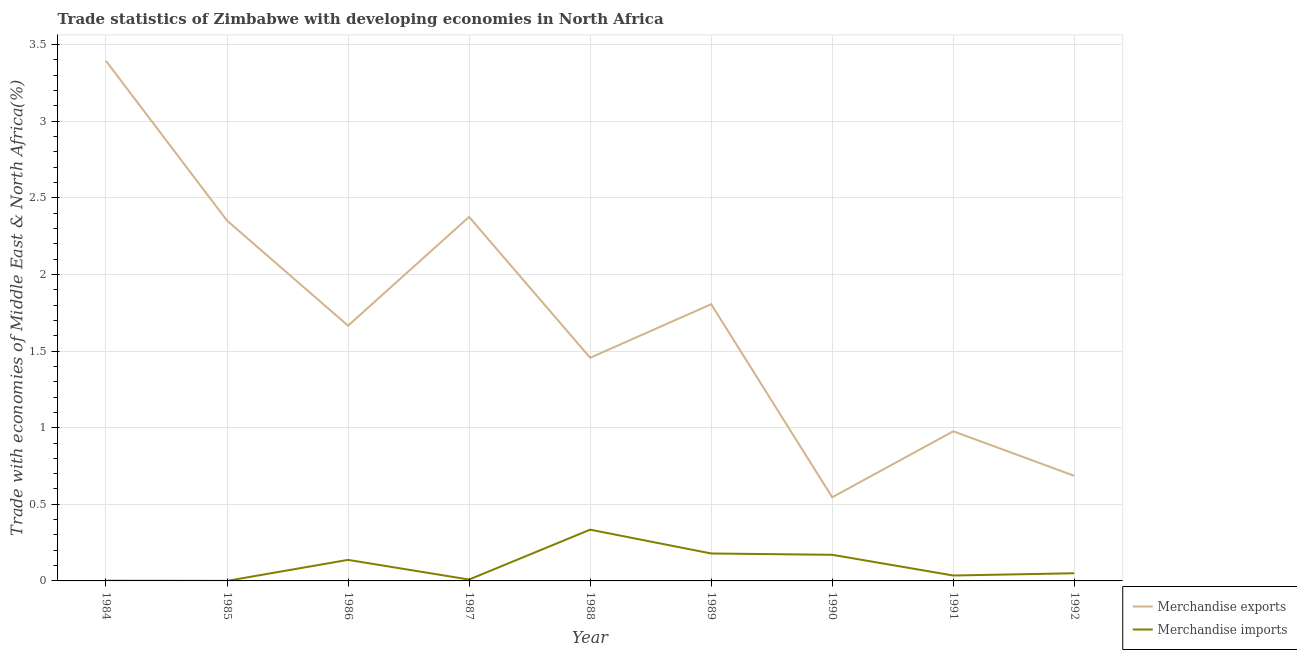How many different coloured lines are there?
Your response must be concise. 2. Is the number of lines equal to the number of legend labels?
Keep it short and to the point. Yes. What is the merchandise exports in 1984?
Provide a short and direct response. 3.39. Across all years, what is the maximum merchandise imports?
Your response must be concise. 0.33. Across all years, what is the minimum merchandise exports?
Give a very brief answer. 0.55. What is the total merchandise exports in the graph?
Your answer should be very brief. 15.26. What is the difference between the merchandise exports in 1987 and that in 1992?
Ensure brevity in your answer.  1.69. What is the difference between the merchandise exports in 1989 and the merchandise imports in 1987?
Offer a very short reply. 1.8. What is the average merchandise exports per year?
Offer a terse response. 1.7. In the year 1991, what is the difference between the merchandise imports and merchandise exports?
Keep it short and to the point. -0.94. What is the ratio of the merchandise exports in 1990 to that in 1992?
Make the answer very short. 0.8. Is the merchandise imports in 1985 less than that in 1988?
Your response must be concise. Yes. Is the difference between the merchandise imports in 1990 and 1992 greater than the difference between the merchandise exports in 1990 and 1992?
Keep it short and to the point. Yes. What is the difference between the highest and the second highest merchandise exports?
Your answer should be very brief. 1.02. What is the difference between the highest and the lowest merchandise imports?
Offer a very short reply. 0.33. Is the merchandise imports strictly greater than the merchandise exports over the years?
Your response must be concise. No. How many years are there in the graph?
Your answer should be very brief. 9. What is the difference between two consecutive major ticks on the Y-axis?
Ensure brevity in your answer.  0.5. Are the values on the major ticks of Y-axis written in scientific E-notation?
Ensure brevity in your answer.  No. Does the graph contain any zero values?
Offer a terse response. No. Does the graph contain grids?
Give a very brief answer. Yes. How many legend labels are there?
Your answer should be compact. 2. How are the legend labels stacked?
Make the answer very short. Vertical. What is the title of the graph?
Make the answer very short. Trade statistics of Zimbabwe with developing economies in North Africa. What is the label or title of the Y-axis?
Ensure brevity in your answer.  Trade with economies of Middle East & North Africa(%). What is the Trade with economies of Middle East & North Africa(%) in Merchandise exports in 1984?
Provide a short and direct response. 3.39. What is the Trade with economies of Middle East & North Africa(%) of Merchandise imports in 1984?
Offer a terse response. 0. What is the Trade with economies of Middle East & North Africa(%) in Merchandise exports in 1985?
Offer a terse response. 2.35. What is the Trade with economies of Middle East & North Africa(%) in Merchandise imports in 1985?
Your answer should be very brief. 0. What is the Trade with economies of Middle East & North Africa(%) of Merchandise exports in 1986?
Provide a short and direct response. 1.67. What is the Trade with economies of Middle East & North Africa(%) of Merchandise imports in 1986?
Keep it short and to the point. 0.14. What is the Trade with economies of Middle East & North Africa(%) of Merchandise exports in 1987?
Offer a very short reply. 2.38. What is the Trade with economies of Middle East & North Africa(%) of Merchandise imports in 1987?
Provide a succinct answer. 0.01. What is the Trade with economies of Middle East & North Africa(%) of Merchandise exports in 1988?
Make the answer very short. 1.46. What is the Trade with economies of Middle East & North Africa(%) in Merchandise imports in 1988?
Keep it short and to the point. 0.33. What is the Trade with economies of Middle East & North Africa(%) in Merchandise exports in 1989?
Give a very brief answer. 1.81. What is the Trade with economies of Middle East & North Africa(%) of Merchandise imports in 1989?
Your answer should be very brief. 0.18. What is the Trade with economies of Middle East & North Africa(%) of Merchandise exports in 1990?
Your response must be concise. 0.55. What is the Trade with economies of Middle East & North Africa(%) in Merchandise imports in 1990?
Your answer should be compact. 0.17. What is the Trade with economies of Middle East & North Africa(%) of Merchandise exports in 1991?
Offer a terse response. 0.98. What is the Trade with economies of Middle East & North Africa(%) in Merchandise imports in 1991?
Make the answer very short. 0.04. What is the Trade with economies of Middle East & North Africa(%) of Merchandise exports in 1992?
Give a very brief answer. 0.69. What is the Trade with economies of Middle East & North Africa(%) of Merchandise imports in 1992?
Provide a short and direct response. 0.05. Across all years, what is the maximum Trade with economies of Middle East & North Africa(%) of Merchandise exports?
Your response must be concise. 3.39. Across all years, what is the maximum Trade with economies of Middle East & North Africa(%) in Merchandise imports?
Your response must be concise. 0.33. Across all years, what is the minimum Trade with economies of Middle East & North Africa(%) in Merchandise exports?
Offer a terse response. 0.55. Across all years, what is the minimum Trade with economies of Middle East & North Africa(%) in Merchandise imports?
Give a very brief answer. 0. What is the total Trade with economies of Middle East & North Africa(%) in Merchandise exports in the graph?
Provide a succinct answer. 15.26. What is the total Trade with economies of Middle East & North Africa(%) in Merchandise imports in the graph?
Make the answer very short. 0.92. What is the difference between the Trade with economies of Middle East & North Africa(%) of Merchandise exports in 1984 and that in 1985?
Give a very brief answer. 1.04. What is the difference between the Trade with economies of Middle East & North Africa(%) of Merchandise imports in 1984 and that in 1985?
Make the answer very short. 0. What is the difference between the Trade with economies of Middle East & North Africa(%) in Merchandise exports in 1984 and that in 1986?
Offer a terse response. 1.73. What is the difference between the Trade with economies of Middle East & North Africa(%) of Merchandise imports in 1984 and that in 1986?
Your answer should be compact. -0.14. What is the difference between the Trade with economies of Middle East & North Africa(%) in Merchandise exports in 1984 and that in 1987?
Provide a short and direct response. 1.02. What is the difference between the Trade with economies of Middle East & North Africa(%) in Merchandise imports in 1984 and that in 1987?
Your response must be concise. -0.01. What is the difference between the Trade with economies of Middle East & North Africa(%) in Merchandise exports in 1984 and that in 1988?
Offer a terse response. 1.94. What is the difference between the Trade with economies of Middle East & North Africa(%) in Merchandise imports in 1984 and that in 1988?
Ensure brevity in your answer.  -0.33. What is the difference between the Trade with economies of Middle East & North Africa(%) in Merchandise exports in 1984 and that in 1989?
Your answer should be compact. 1.59. What is the difference between the Trade with economies of Middle East & North Africa(%) in Merchandise imports in 1984 and that in 1989?
Provide a short and direct response. -0.18. What is the difference between the Trade with economies of Middle East & North Africa(%) in Merchandise exports in 1984 and that in 1990?
Your answer should be very brief. 2.85. What is the difference between the Trade with economies of Middle East & North Africa(%) in Merchandise imports in 1984 and that in 1990?
Offer a terse response. -0.17. What is the difference between the Trade with economies of Middle East & North Africa(%) in Merchandise exports in 1984 and that in 1991?
Provide a succinct answer. 2.42. What is the difference between the Trade with economies of Middle East & North Africa(%) in Merchandise imports in 1984 and that in 1991?
Your answer should be compact. -0.03. What is the difference between the Trade with economies of Middle East & North Africa(%) of Merchandise exports in 1984 and that in 1992?
Provide a succinct answer. 2.71. What is the difference between the Trade with economies of Middle East & North Africa(%) of Merchandise imports in 1984 and that in 1992?
Your answer should be very brief. -0.05. What is the difference between the Trade with economies of Middle East & North Africa(%) in Merchandise exports in 1985 and that in 1986?
Provide a succinct answer. 0.69. What is the difference between the Trade with economies of Middle East & North Africa(%) in Merchandise imports in 1985 and that in 1986?
Provide a short and direct response. -0.14. What is the difference between the Trade with economies of Middle East & North Africa(%) of Merchandise exports in 1985 and that in 1987?
Your answer should be very brief. -0.02. What is the difference between the Trade with economies of Middle East & North Africa(%) of Merchandise imports in 1985 and that in 1987?
Offer a terse response. -0.01. What is the difference between the Trade with economies of Middle East & North Africa(%) in Merchandise exports in 1985 and that in 1988?
Your response must be concise. 0.9. What is the difference between the Trade with economies of Middle East & North Africa(%) of Merchandise imports in 1985 and that in 1988?
Ensure brevity in your answer.  -0.33. What is the difference between the Trade with economies of Middle East & North Africa(%) of Merchandise exports in 1985 and that in 1989?
Offer a terse response. 0.55. What is the difference between the Trade with economies of Middle East & North Africa(%) in Merchandise imports in 1985 and that in 1989?
Your response must be concise. -0.18. What is the difference between the Trade with economies of Middle East & North Africa(%) in Merchandise exports in 1985 and that in 1990?
Keep it short and to the point. 1.81. What is the difference between the Trade with economies of Middle East & North Africa(%) in Merchandise imports in 1985 and that in 1990?
Offer a very short reply. -0.17. What is the difference between the Trade with economies of Middle East & North Africa(%) in Merchandise exports in 1985 and that in 1991?
Your answer should be compact. 1.38. What is the difference between the Trade with economies of Middle East & North Africa(%) of Merchandise imports in 1985 and that in 1991?
Your answer should be very brief. -0.04. What is the difference between the Trade with economies of Middle East & North Africa(%) in Merchandise exports in 1985 and that in 1992?
Provide a short and direct response. 1.67. What is the difference between the Trade with economies of Middle East & North Africa(%) of Merchandise imports in 1985 and that in 1992?
Your answer should be very brief. -0.05. What is the difference between the Trade with economies of Middle East & North Africa(%) in Merchandise exports in 1986 and that in 1987?
Offer a very short reply. -0.71. What is the difference between the Trade with economies of Middle East & North Africa(%) in Merchandise imports in 1986 and that in 1987?
Offer a very short reply. 0.13. What is the difference between the Trade with economies of Middle East & North Africa(%) in Merchandise exports in 1986 and that in 1988?
Your answer should be compact. 0.21. What is the difference between the Trade with economies of Middle East & North Africa(%) in Merchandise imports in 1986 and that in 1988?
Provide a succinct answer. -0.2. What is the difference between the Trade with economies of Middle East & North Africa(%) in Merchandise exports in 1986 and that in 1989?
Provide a succinct answer. -0.14. What is the difference between the Trade with economies of Middle East & North Africa(%) of Merchandise imports in 1986 and that in 1989?
Make the answer very short. -0.04. What is the difference between the Trade with economies of Middle East & North Africa(%) in Merchandise exports in 1986 and that in 1990?
Your answer should be very brief. 1.12. What is the difference between the Trade with economies of Middle East & North Africa(%) of Merchandise imports in 1986 and that in 1990?
Offer a very short reply. -0.03. What is the difference between the Trade with economies of Middle East & North Africa(%) in Merchandise exports in 1986 and that in 1991?
Your answer should be very brief. 0.69. What is the difference between the Trade with economies of Middle East & North Africa(%) of Merchandise imports in 1986 and that in 1991?
Provide a short and direct response. 0.1. What is the difference between the Trade with economies of Middle East & North Africa(%) in Merchandise imports in 1986 and that in 1992?
Offer a very short reply. 0.09. What is the difference between the Trade with economies of Middle East & North Africa(%) of Merchandise exports in 1987 and that in 1988?
Your response must be concise. 0.92. What is the difference between the Trade with economies of Middle East & North Africa(%) in Merchandise imports in 1987 and that in 1988?
Your response must be concise. -0.33. What is the difference between the Trade with economies of Middle East & North Africa(%) of Merchandise exports in 1987 and that in 1989?
Offer a terse response. 0.57. What is the difference between the Trade with economies of Middle East & North Africa(%) in Merchandise imports in 1987 and that in 1989?
Offer a terse response. -0.17. What is the difference between the Trade with economies of Middle East & North Africa(%) in Merchandise exports in 1987 and that in 1990?
Offer a very short reply. 1.83. What is the difference between the Trade with economies of Middle East & North Africa(%) in Merchandise imports in 1987 and that in 1990?
Your answer should be compact. -0.16. What is the difference between the Trade with economies of Middle East & North Africa(%) of Merchandise exports in 1987 and that in 1991?
Give a very brief answer. 1.4. What is the difference between the Trade with economies of Middle East & North Africa(%) in Merchandise imports in 1987 and that in 1991?
Ensure brevity in your answer.  -0.03. What is the difference between the Trade with economies of Middle East & North Africa(%) in Merchandise exports in 1987 and that in 1992?
Keep it short and to the point. 1.69. What is the difference between the Trade with economies of Middle East & North Africa(%) in Merchandise imports in 1987 and that in 1992?
Offer a terse response. -0.04. What is the difference between the Trade with economies of Middle East & North Africa(%) in Merchandise exports in 1988 and that in 1989?
Give a very brief answer. -0.35. What is the difference between the Trade with economies of Middle East & North Africa(%) of Merchandise imports in 1988 and that in 1989?
Ensure brevity in your answer.  0.16. What is the difference between the Trade with economies of Middle East & North Africa(%) in Merchandise exports in 1988 and that in 1990?
Ensure brevity in your answer.  0.91. What is the difference between the Trade with economies of Middle East & North Africa(%) of Merchandise imports in 1988 and that in 1990?
Make the answer very short. 0.16. What is the difference between the Trade with economies of Middle East & North Africa(%) of Merchandise exports in 1988 and that in 1991?
Provide a short and direct response. 0.48. What is the difference between the Trade with economies of Middle East & North Africa(%) in Merchandise imports in 1988 and that in 1991?
Provide a short and direct response. 0.3. What is the difference between the Trade with economies of Middle East & North Africa(%) in Merchandise exports in 1988 and that in 1992?
Keep it short and to the point. 0.77. What is the difference between the Trade with economies of Middle East & North Africa(%) in Merchandise imports in 1988 and that in 1992?
Provide a short and direct response. 0.28. What is the difference between the Trade with economies of Middle East & North Africa(%) of Merchandise exports in 1989 and that in 1990?
Offer a terse response. 1.26. What is the difference between the Trade with economies of Middle East & North Africa(%) of Merchandise imports in 1989 and that in 1990?
Offer a terse response. 0.01. What is the difference between the Trade with economies of Middle East & North Africa(%) of Merchandise exports in 1989 and that in 1991?
Offer a very short reply. 0.83. What is the difference between the Trade with economies of Middle East & North Africa(%) in Merchandise imports in 1989 and that in 1991?
Ensure brevity in your answer.  0.14. What is the difference between the Trade with economies of Middle East & North Africa(%) in Merchandise exports in 1989 and that in 1992?
Your response must be concise. 1.12. What is the difference between the Trade with economies of Middle East & North Africa(%) in Merchandise imports in 1989 and that in 1992?
Provide a succinct answer. 0.13. What is the difference between the Trade with economies of Middle East & North Africa(%) in Merchandise exports in 1990 and that in 1991?
Ensure brevity in your answer.  -0.43. What is the difference between the Trade with economies of Middle East & North Africa(%) of Merchandise imports in 1990 and that in 1991?
Provide a short and direct response. 0.14. What is the difference between the Trade with economies of Middle East & North Africa(%) of Merchandise exports in 1990 and that in 1992?
Offer a terse response. -0.14. What is the difference between the Trade with economies of Middle East & North Africa(%) of Merchandise imports in 1990 and that in 1992?
Provide a succinct answer. 0.12. What is the difference between the Trade with economies of Middle East & North Africa(%) of Merchandise exports in 1991 and that in 1992?
Provide a short and direct response. 0.29. What is the difference between the Trade with economies of Middle East & North Africa(%) in Merchandise imports in 1991 and that in 1992?
Provide a short and direct response. -0.01. What is the difference between the Trade with economies of Middle East & North Africa(%) of Merchandise exports in 1984 and the Trade with economies of Middle East & North Africa(%) of Merchandise imports in 1985?
Ensure brevity in your answer.  3.39. What is the difference between the Trade with economies of Middle East & North Africa(%) in Merchandise exports in 1984 and the Trade with economies of Middle East & North Africa(%) in Merchandise imports in 1986?
Provide a short and direct response. 3.26. What is the difference between the Trade with economies of Middle East & North Africa(%) of Merchandise exports in 1984 and the Trade with economies of Middle East & North Africa(%) of Merchandise imports in 1987?
Make the answer very short. 3.38. What is the difference between the Trade with economies of Middle East & North Africa(%) of Merchandise exports in 1984 and the Trade with economies of Middle East & North Africa(%) of Merchandise imports in 1988?
Provide a short and direct response. 3.06. What is the difference between the Trade with economies of Middle East & North Africa(%) of Merchandise exports in 1984 and the Trade with economies of Middle East & North Africa(%) of Merchandise imports in 1989?
Your response must be concise. 3.21. What is the difference between the Trade with economies of Middle East & North Africa(%) of Merchandise exports in 1984 and the Trade with economies of Middle East & North Africa(%) of Merchandise imports in 1990?
Offer a very short reply. 3.22. What is the difference between the Trade with economies of Middle East & North Africa(%) in Merchandise exports in 1984 and the Trade with economies of Middle East & North Africa(%) in Merchandise imports in 1991?
Offer a very short reply. 3.36. What is the difference between the Trade with economies of Middle East & North Africa(%) of Merchandise exports in 1984 and the Trade with economies of Middle East & North Africa(%) of Merchandise imports in 1992?
Your answer should be compact. 3.34. What is the difference between the Trade with economies of Middle East & North Africa(%) of Merchandise exports in 1985 and the Trade with economies of Middle East & North Africa(%) of Merchandise imports in 1986?
Make the answer very short. 2.21. What is the difference between the Trade with economies of Middle East & North Africa(%) in Merchandise exports in 1985 and the Trade with economies of Middle East & North Africa(%) in Merchandise imports in 1987?
Your response must be concise. 2.34. What is the difference between the Trade with economies of Middle East & North Africa(%) of Merchandise exports in 1985 and the Trade with economies of Middle East & North Africa(%) of Merchandise imports in 1988?
Your answer should be very brief. 2.02. What is the difference between the Trade with economies of Middle East & North Africa(%) in Merchandise exports in 1985 and the Trade with economies of Middle East & North Africa(%) in Merchandise imports in 1989?
Make the answer very short. 2.17. What is the difference between the Trade with economies of Middle East & North Africa(%) in Merchandise exports in 1985 and the Trade with economies of Middle East & North Africa(%) in Merchandise imports in 1990?
Provide a succinct answer. 2.18. What is the difference between the Trade with economies of Middle East & North Africa(%) of Merchandise exports in 1985 and the Trade with economies of Middle East & North Africa(%) of Merchandise imports in 1991?
Offer a terse response. 2.32. What is the difference between the Trade with economies of Middle East & North Africa(%) of Merchandise exports in 1985 and the Trade with economies of Middle East & North Africa(%) of Merchandise imports in 1992?
Your answer should be very brief. 2.3. What is the difference between the Trade with economies of Middle East & North Africa(%) in Merchandise exports in 1986 and the Trade with economies of Middle East & North Africa(%) in Merchandise imports in 1987?
Provide a succinct answer. 1.66. What is the difference between the Trade with economies of Middle East & North Africa(%) in Merchandise exports in 1986 and the Trade with economies of Middle East & North Africa(%) in Merchandise imports in 1988?
Your answer should be very brief. 1.33. What is the difference between the Trade with economies of Middle East & North Africa(%) in Merchandise exports in 1986 and the Trade with economies of Middle East & North Africa(%) in Merchandise imports in 1989?
Offer a terse response. 1.49. What is the difference between the Trade with economies of Middle East & North Africa(%) in Merchandise exports in 1986 and the Trade with economies of Middle East & North Africa(%) in Merchandise imports in 1990?
Keep it short and to the point. 1.5. What is the difference between the Trade with economies of Middle East & North Africa(%) of Merchandise exports in 1986 and the Trade with economies of Middle East & North Africa(%) of Merchandise imports in 1991?
Provide a succinct answer. 1.63. What is the difference between the Trade with economies of Middle East & North Africa(%) of Merchandise exports in 1986 and the Trade with economies of Middle East & North Africa(%) of Merchandise imports in 1992?
Provide a succinct answer. 1.62. What is the difference between the Trade with economies of Middle East & North Africa(%) in Merchandise exports in 1987 and the Trade with economies of Middle East & North Africa(%) in Merchandise imports in 1988?
Give a very brief answer. 2.04. What is the difference between the Trade with economies of Middle East & North Africa(%) in Merchandise exports in 1987 and the Trade with economies of Middle East & North Africa(%) in Merchandise imports in 1989?
Offer a terse response. 2.2. What is the difference between the Trade with economies of Middle East & North Africa(%) of Merchandise exports in 1987 and the Trade with economies of Middle East & North Africa(%) of Merchandise imports in 1990?
Make the answer very short. 2.21. What is the difference between the Trade with economies of Middle East & North Africa(%) of Merchandise exports in 1987 and the Trade with economies of Middle East & North Africa(%) of Merchandise imports in 1991?
Keep it short and to the point. 2.34. What is the difference between the Trade with economies of Middle East & North Africa(%) in Merchandise exports in 1987 and the Trade with economies of Middle East & North Africa(%) in Merchandise imports in 1992?
Offer a terse response. 2.33. What is the difference between the Trade with economies of Middle East & North Africa(%) of Merchandise exports in 1988 and the Trade with economies of Middle East & North Africa(%) of Merchandise imports in 1989?
Your answer should be compact. 1.28. What is the difference between the Trade with economies of Middle East & North Africa(%) of Merchandise exports in 1988 and the Trade with economies of Middle East & North Africa(%) of Merchandise imports in 1990?
Your answer should be compact. 1.29. What is the difference between the Trade with economies of Middle East & North Africa(%) of Merchandise exports in 1988 and the Trade with economies of Middle East & North Africa(%) of Merchandise imports in 1991?
Your answer should be very brief. 1.42. What is the difference between the Trade with economies of Middle East & North Africa(%) in Merchandise exports in 1988 and the Trade with economies of Middle East & North Africa(%) in Merchandise imports in 1992?
Your answer should be compact. 1.41. What is the difference between the Trade with economies of Middle East & North Africa(%) of Merchandise exports in 1989 and the Trade with economies of Middle East & North Africa(%) of Merchandise imports in 1990?
Your answer should be compact. 1.64. What is the difference between the Trade with economies of Middle East & North Africa(%) of Merchandise exports in 1989 and the Trade with economies of Middle East & North Africa(%) of Merchandise imports in 1991?
Keep it short and to the point. 1.77. What is the difference between the Trade with economies of Middle East & North Africa(%) in Merchandise exports in 1989 and the Trade with economies of Middle East & North Africa(%) in Merchandise imports in 1992?
Your answer should be very brief. 1.76. What is the difference between the Trade with economies of Middle East & North Africa(%) of Merchandise exports in 1990 and the Trade with economies of Middle East & North Africa(%) of Merchandise imports in 1991?
Your answer should be compact. 0.51. What is the difference between the Trade with economies of Middle East & North Africa(%) of Merchandise exports in 1990 and the Trade with economies of Middle East & North Africa(%) of Merchandise imports in 1992?
Give a very brief answer. 0.5. What is the difference between the Trade with economies of Middle East & North Africa(%) in Merchandise exports in 1991 and the Trade with economies of Middle East & North Africa(%) in Merchandise imports in 1992?
Your response must be concise. 0.93. What is the average Trade with economies of Middle East & North Africa(%) in Merchandise exports per year?
Provide a short and direct response. 1.7. What is the average Trade with economies of Middle East & North Africa(%) in Merchandise imports per year?
Provide a succinct answer. 0.1. In the year 1984, what is the difference between the Trade with economies of Middle East & North Africa(%) of Merchandise exports and Trade with economies of Middle East & North Africa(%) of Merchandise imports?
Your answer should be very brief. 3.39. In the year 1985, what is the difference between the Trade with economies of Middle East & North Africa(%) of Merchandise exports and Trade with economies of Middle East & North Africa(%) of Merchandise imports?
Provide a succinct answer. 2.35. In the year 1986, what is the difference between the Trade with economies of Middle East & North Africa(%) in Merchandise exports and Trade with economies of Middle East & North Africa(%) in Merchandise imports?
Your answer should be very brief. 1.53. In the year 1987, what is the difference between the Trade with economies of Middle East & North Africa(%) of Merchandise exports and Trade with economies of Middle East & North Africa(%) of Merchandise imports?
Provide a short and direct response. 2.37. In the year 1988, what is the difference between the Trade with economies of Middle East & North Africa(%) of Merchandise exports and Trade with economies of Middle East & North Africa(%) of Merchandise imports?
Provide a short and direct response. 1.12. In the year 1989, what is the difference between the Trade with economies of Middle East & North Africa(%) in Merchandise exports and Trade with economies of Middle East & North Africa(%) in Merchandise imports?
Make the answer very short. 1.63. In the year 1990, what is the difference between the Trade with economies of Middle East & North Africa(%) in Merchandise exports and Trade with economies of Middle East & North Africa(%) in Merchandise imports?
Offer a very short reply. 0.38. In the year 1991, what is the difference between the Trade with economies of Middle East & North Africa(%) in Merchandise exports and Trade with economies of Middle East & North Africa(%) in Merchandise imports?
Give a very brief answer. 0.94. In the year 1992, what is the difference between the Trade with economies of Middle East & North Africa(%) in Merchandise exports and Trade with economies of Middle East & North Africa(%) in Merchandise imports?
Ensure brevity in your answer.  0.64. What is the ratio of the Trade with economies of Middle East & North Africa(%) in Merchandise exports in 1984 to that in 1985?
Offer a terse response. 1.44. What is the ratio of the Trade with economies of Middle East & North Africa(%) in Merchandise imports in 1984 to that in 1985?
Make the answer very short. 4.99. What is the ratio of the Trade with economies of Middle East & North Africa(%) of Merchandise exports in 1984 to that in 1986?
Offer a terse response. 2.04. What is the ratio of the Trade with economies of Middle East & North Africa(%) in Merchandise imports in 1984 to that in 1986?
Make the answer very short. 0.01. What is the ratio of the Trade with economies of Middle East & North Africa(%) of Merchandise exports in 1984 to that in 1987?
Make the answer very short. 1.43. What is the ratio of the Trade with economies of Middle East & North Africa(%) in Merchandise imports in 1984 to that in 1987?
Ensure brevity in your answer.  0.17. What is the ratio of the Trade with economies of Middle East & North Africa(%) in Merchandise exports in 1984 to that in 1988?
Your answer should be compact. 2.33. What is the ratio of the Trade with economies of Middle East & North Africa(%) of Merchandise imports in 1984 to that in 1988?
Ensure brevity in your answer.  0. What is the ratio of the Trade with economies of Middle East & North Africa(%) of Merchandise exports in 1984 to that in 1989?
Your answer should be very brief. 1.88. What is the ratio of the Trade with economies of Middle East & North Africa(%) in Merchandise imports in 1984 to that in 1989?
Give a very brief answer. 0.01. What is the ratio of the Trade with economies of Middle East & North Africa(%) of Merchandise exports in 1984 to that in 1990?
Your response must be concise. 6.22. What is the ratio of the Trade with economies of Middle East & North Africa(%) of Merchandise imports in 1984 to that in 1990?
Provide a short and direct response. 0.01. What is the ratio of the Trade with economies of Middle East & North Africa(%) in Merchandise exports in 1984 to that in 1991?
Your answer should be compact. 3.48. What is the ratio of the Trade with economies of Middle East & North Africa(%) in Merchandise imports in 1984 to that in 1991?
Your answer should be compact. 0.04. What is the ratio of the Trade with economies of Middle East & North Africa(%) of Merchandise exports in 1984 to that in 1992?
Offer a very short reply. 4.95. What is the ratio of the Trade with economies of Middle East & North Africa(%) in Merchandise imports in 1984 to that in 1992?
Give a very brief answer. 0.03. What is the ratio of the Trade with economies of Middle East & North Africa(%) in Merchandise exports in 1985 to that in 1986?
Ensure brevity in your answer.  1.41. What is the ratio of the Trade with economies of Middle East & North Africa(%) in Merchandise imports in 1985 to that in 1986?
Offer a very short reply. 0. What is the ratio of the Trade with economies of Middle East & North Africa(%) in Merchandise imports in 1985 to that in 1987?
Make the answer very short. 0.03. What is the ratio of the Trade with economies of Middle East & North Africa(%) of Merchandise exports in 1985 to that in 1988?
Your response must be concise. 1.61. What is the ratio of the Trade with economies of Middle East & North Africa(%) in Merchandise imports in 1985 to that in 1988?
Your answer should be very brief. 0. What is the ratio of the Trade with economies of Middle East & North Africa(%) of Merchandise exports in 1985 to that in 1989?
Provide a succinct answer. 1.3. What is the ratio of the Trade with economies of Middle East & North Africa(%) of Merchandise imports in 1985 to that in 1989?
Your response must be concise. 0. What is the ratio of the Trade with economies of Middle East & North Africa(%) in Merchandise exports in 1985 to that in 1990?
Ensure brevity in your answer.  4.31. What is the ratio of the Trade with economies of Middle East & North Africa(%) in Merchandise imports in 1985 to that in 1990?
Your answer should be very brief. 0. What is the ratio of the Trade with economies of Middle East & North Africa(%) of Merchandise exports in 1985 to that in 1991?
Provide a short and direct response. 2.41. What is the ratio of the Trade with economies of Middle East & North Africa(%) of Merchandise imports in 1985 to that in 1991?
Give a very brief answer. 0.01. What is the ratio of the Trade with economies of Middle East & North Africa(%) in Merchandise exports in 1985 to that in 1992?
Make the answer very short. 3.43. What is the ratio of the Trade with economies of Middle East & North Africa(%) in Merchandise imports in 1985 to that in 1992?
Make the answer very short. 0.01. What is the ratio of the Trade with economies of Middle East & North Africa(%) in Merchandise exports in 1986 to that in 1987?
Give a very brief answer. 0.7. What is the ratio of the Trade with economies of Middle East & North Africa(%) of Merchandise imports in 1986 to that in 1987?
Your answer should be compact. 15.36. What is the ratio of the Trade with economies of Middle East & North Africa(%) of Merchandise exports in 1986 to that in 1988?
Keep it short and to the point. 1.14. What is the ratio of the Trade with economies of Middle East & North Africa(%) of Merchandise imports in 1986 to that in 1988?
Your response must be concise. 0.41. What is the ratio of the Trade with economies of Middle East & North Africa(%) of Merchandise exports in 1986 to that in 1989?
Offer a terse response. 0.92. What is the ratio of the Trade with economies of Middle East & North Africa(%) of Merchandise imports in 1986 to that in 1989?
Offer a very short reply. 0.77. What is the ratio of the Trade with economies of Middle East & North Africa(%) in Merchandise exports in 1986 to that in 1990?
Give a very brief answer. 3.05. What is the ratio of the Trade with economies of Middle East & North Africa(%) in Merchandise imports in 1986 to that in 1990?
Make the answer very short. 0.81. What is the ratio of the Trade with economies of Middle East & North Africa(%) in Merchandise exports in 1986 to that in 1991?
Keep it short and to the point. 1.71. What is the ratio of the Trade with economies of Middle East & North Africa(%) in Merchandise imports in 1986 to that in 1991?
Make the answer very short. 3.89. What is the ratio of the Trade with economies of Middle East & North Africa(%) of Merchandise exports in 1986 to that in 1992?
Provide a short and direct response. 2.43. What is the ratio of the Trade with economies of Middle East & North Africa(%) of Merchandise imports in 1986 to that in 1992?
Offer a terse response. 2.74. What is the ratio of the Trade with economies of Middle East & North Africa(%) in Merchandise exports in 1987 to that in 1988?
Offer a very short reply. 1.63. What is the ratio of the Trade with economies of Middle East & North Africa(%) in Merchandise imports in 1987 to that in 1988?
Ensure brevity in your answer.  0.03. What is the ratio of the Trade with economies of Middle East & North Africa(%) in Merchandise exports in 1987 to that in 1989?
Provide a succinct answer. 1.32. What is the ratio of the Trade with economies of Middle East & North Africa(%) in Merchandise imports in 1987 to that in 1989?
Your answer should be very brief. 0.05. What is the ratio of the Trade with economies of Middle East & North Africa(%) of Merchandise exports in 1987 to that in 1990?
Provide a short and direct response. 4.35. What is the ratio of the Trade with economies of Middle East & North Africa(%) in Merchandise imports in 1987 to that in 1990?
Provide a succinct answer. 0.05. What is the ratio of the Trade with economies of Middle East & North Africa(%) in Merchandise exports in 1987 to that in 1991?
Provide a succinct answer. 2.43. What is the ratio of the Trade with economies of Middle East & North Africa(%) of Merchandise imports in 1987 to that in 1991?
Your answer should be compact. 0.25. What is the ratio of the Trade with economies of Middle East & North Africa(%) in Merchandise exports in 1987 to that in 1992?
Provide a succinct answer. 3.46. What is the ratio of the Trade with economies of Middle East & North Africa(%) of Merchandise imports in 1987 to that in 1992?
Your answer should be very brief. 0.18. What is the ratio of the Trade with economies of Middle East & North Africa(%) in Merchandise exports in 1988 to that in 1989?
Keep it short and to the point. 0.81. What is the ratio of the Trade with economies of Middle East & North Africa(%) of Merchandise imports in 1988 to that in 1989?
Ensure brevity in your answer.  1.87. What is the ratio of the Trade with economies of Middle East & North Africa(%) of Merchandise exports in 1988 to that in 1990?
Your response must be concise. 2.67. What is the ratio of the Trade with economies of Middle East & North Africa(%) in Merchandise imports in 1988 to that in 1990?
Your answer should be compact. 1.96. What is the ratio of the Trade with economies of Middle East & North Africa(%) in Merchandise exports in 1988 to that in 1991?
Provide a short and direct response. 1.49. What is the ratio of the Trade with economies of Middle East & North Africa(%) of Merchandise imports in 1988 to that in 1991?
Keep it short and to the point. 9.47. What is the ratio of the Trade with economies of Middle East & North Africa(%) in Merchandise exports in 1988 to that in 1992?
Offer a very short reply. 2.12. What is the ratio of the Trade with economies of Middle East & North Africa(%) of Merchandise imports in 1988 to that in 1992?
Offer a terse response. 6.68. What is the ratio of the Trade with economies of Middle East & North Africa(%) of Merchandise exports in 1989 to that in 1990?
Your answer should be very brief. 3.31. What is the ratio of the Trade with economies of Middle East & North Africa(%) in Merchandise imports in 1989 to that in 1990?
Make the answer very short. 1.05. What is the ratio of the Trade with economies of Middle East & North Africa(%) of Merchandise exports in 1989 to that in 1991?
Your answer should be compact. 1.85. What is the ratio of the Trade with economies of Middle East & North Africa(%) of Merchandise imports in 1989 to that in 1991?
Provide a short and direct response. 5.07. What is the ratio of the Trade with economies of Middle East & North Africa(%) in Merchandise exports in 1989 to that in 1992?
Your answer should be compact. 2.63. What is the ratio of the Trade with economies of Middle East & North Africa(%) in Merchandise imports in 1989 to that in 1992?
Ensure brevity in your answer.  3.58. What is the ratio of the Trade with economies of Middle East & North Africa(%) in Merchandise exports in 1990 to that in 1991?
Keep it short and to the point. 0.56. What is the ratio of the Trade with economies of Middle East & North Africa(%) in Merchandise imports in 1990 to that in 1991?
Your answer should be very brief. 4.83. What is the ratio of the Trade with economies of Middle East & North Africa(%) in Merchandise exports in 1990 to that in 1992?
Your response must be concise. 0.8. What is the ratio of the Trade with economies of Middle East & North Africa(%) in Merchandise imports in 1990 to that in 1992?
Your answer should be very brief. 3.41. What is the ratio of the Trade with economies of Middle East & North Africa(%) in Merchandise exports in 1991 to that in 1992?
Your response must be concise. 1.42. What is the ratio of the Trade with economies of Middle East & North Africa(%) of Merchandise imports in 1991 to that in 1992?
Provide a short and direct response. 0.71. What is the difference between the highest and the second highest Trade with economies of Middle East & North Africa(%) in Merchandise exports?
Your answer should be very brief. 1.02. What is the difference between the highest and the second highest Trade with economies of Middle East & North Africa(%) in Merchandise imports?
Your answer should be compact. 0.16. What is the difference between the highest and the lowest Trade with economies of Middle East & North Africa(%) in Merchandise exports?
Your answer should be compact. 2.85. What is the difference between the highest and the lowest Trade with economies of Middle East & North Africa(%) of Merchandise imports?
Your response must be concise. 0.33. 